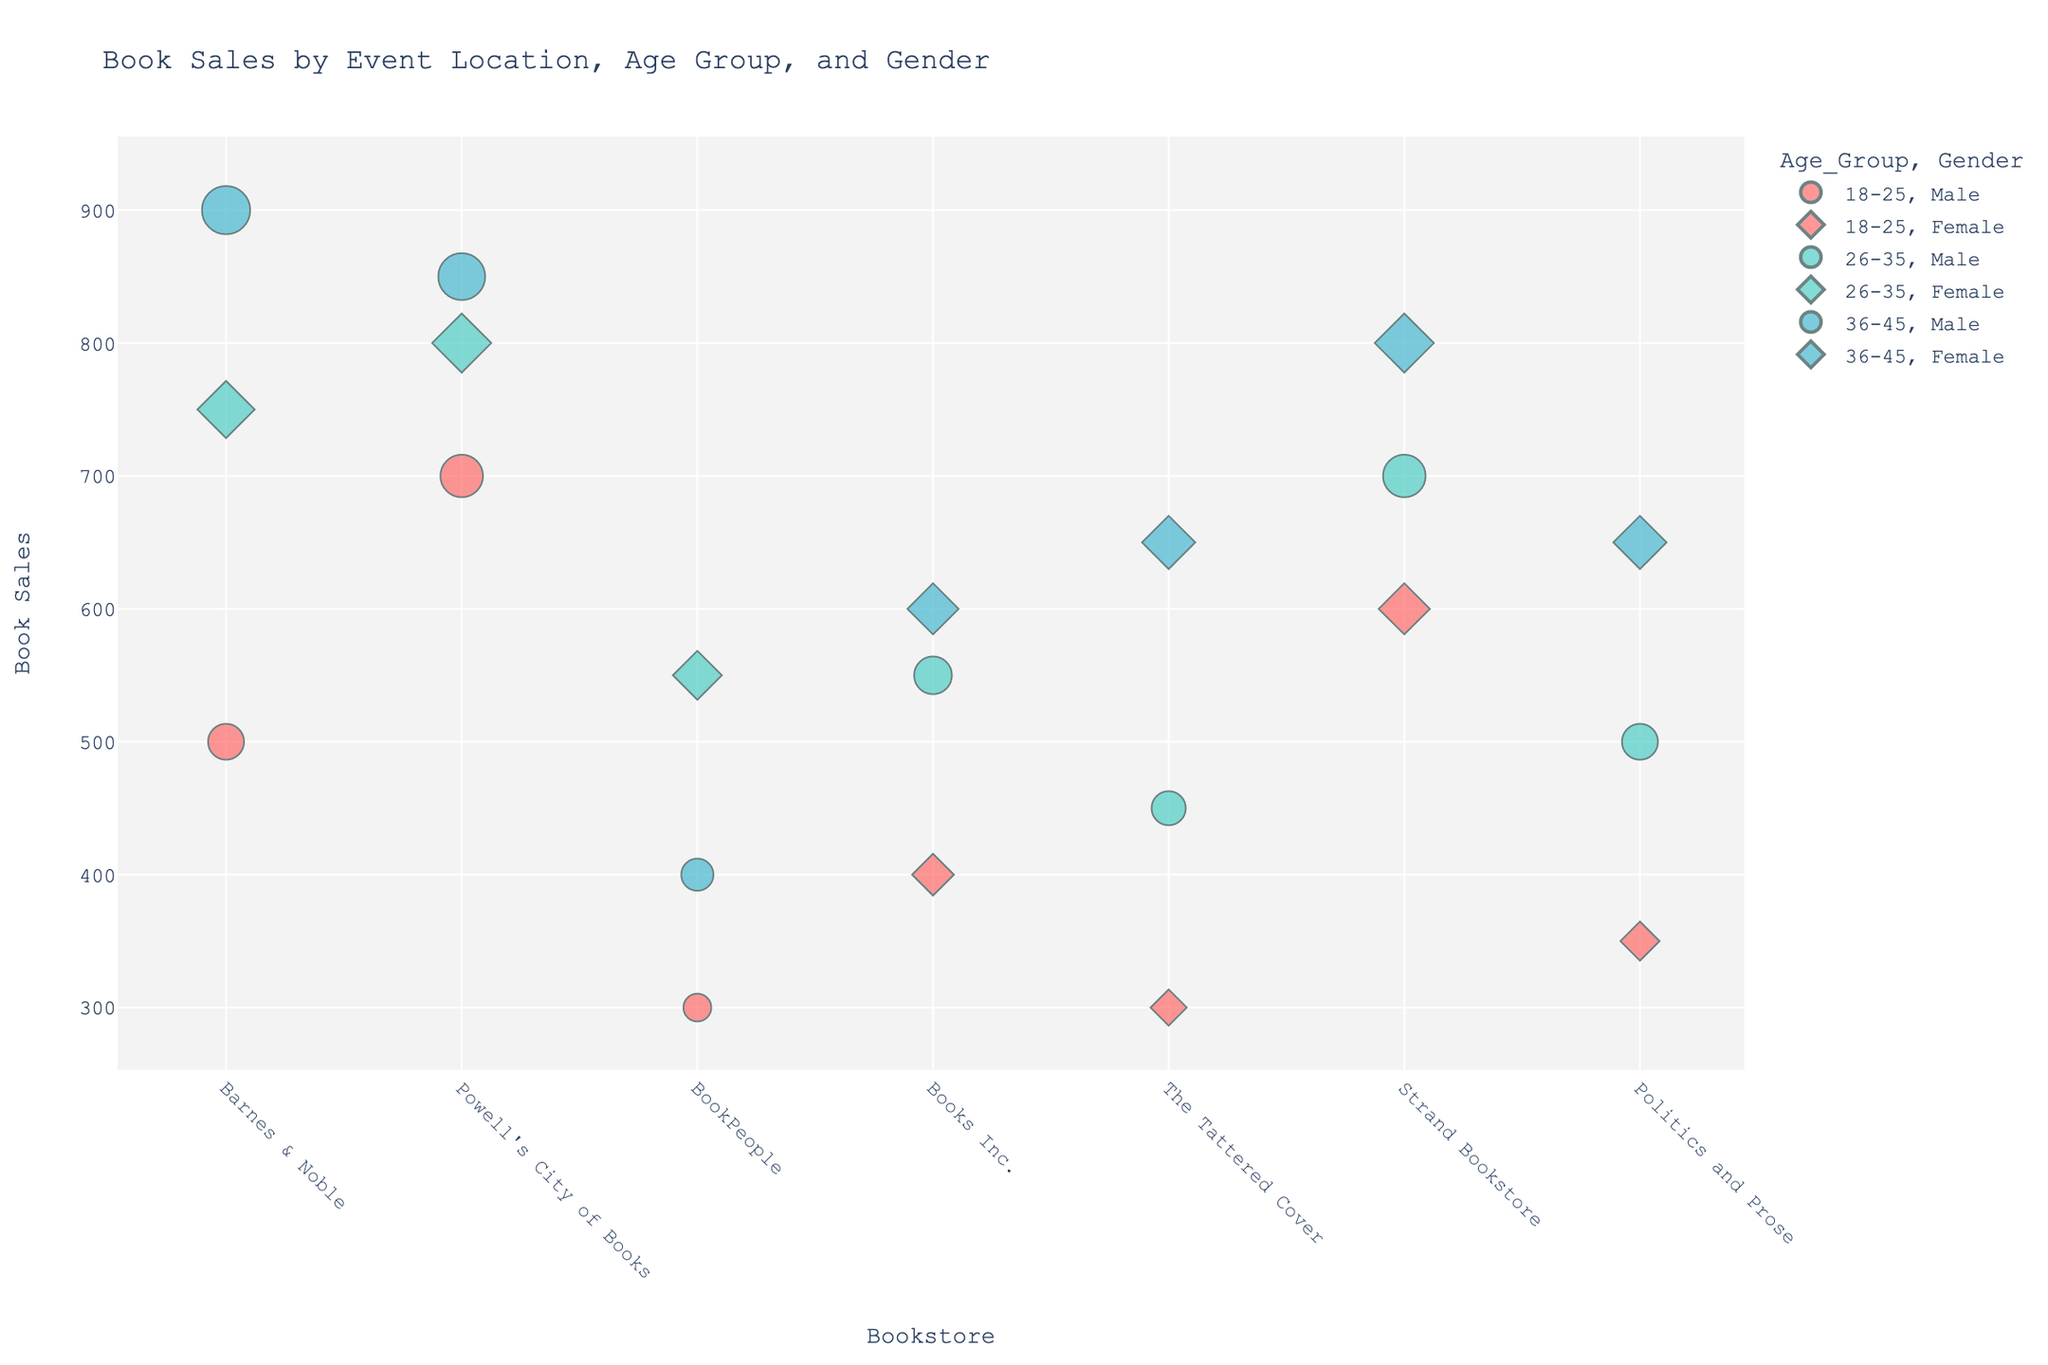what is the event location with the highest sales volume? The event location with the highest sales volume can be determined by identifying the marker with the largest size on the y-axis for Sales Volume. "Barnes & Noble" in New York, NY, has the highest sales volume at 900.
Answer: Barnes & Noble which age group had the highest sales volume at Powell's City of Books? To find this, look at the markers at "Powell's City of Books" and compare their sizes. The 36-45 age group had the highest sales volume at 850.
Answer: 36-45 how does the sales volume for males compare to females across all event locations? To compare, observe the size of the symbols for male versus female across all event locations. Males generally show larger sales volumes in both New York (Barnes & Noble) at 900 and Portland (Powell's City of Books) at 850. Females, while having significant sales volumes, do not surpass males in any given location.
Answer: Males have higher sales volumes what is the total sales volume for the 26-35 age group across all event locations? Sum the sales volumes for the 26-35 age group at each event location: 750 (Barnes & Noble) + 550 (Books Inc.) + 450 (The Tattered Cover) + 800 (Powell's City of Books) + 700 (Strand Bookstore) + 550 (BookPeople) + 500 (Politics and Prose) = 4300.
Answer: 4300 which location has the most balanced gender representation by sales volume? To determine this, compare the sales volumes of males and females at each location. The Tattered Cover in Denver shows balanced sales volumes with 450 for males and 300 & 650 for females, indicating a more equal representation.
Answer: The Tattered Cover how do the sales volumes compare between New York and Portland for the 18-25 age group? Compare the sales volumes for the 18-25 age group in New York (Barnes & Noble 500, Strand Bookstore 600) and Portland (Powell's City of Books 700). The combined sales volumes for each city are 1100 for New York and 700 for Portland.
Answer: New York has higher sales volumes (1100 vs. 700) which event location had the lowest sales volume for males? To find this, locate the smallest symbol for males on the y-axis for each event location. BookPeople in Austin, TX, had the lowest sales volume for males at 300.
Answer: BookPeople what is the median sales volume for the 36-45 age group across all event locations? List the sales volumes for the 36-45 age group: 900 (Barnes & Noble), 600 (Books Inc.), 650 (The Tattered Cover), 850 (Powell's City of Books), 800 (Strand Bookstore), 400 (BookPeople), 650 (Politics and Prose). After sorting (400, 600, 650, 650, 800, 850, 900), the median is 650.
Answer: 650 how does the sales volume in Austin compare to the sales volume in San Francisco for the 26-35 age group? Compare the sales volumes for the 26-35 age group: Austin (BookPeople) has 550, San Francisco (Books Inc.) has 550. Since both are equal, the sales volumes are the same.
Answer: Equal (550 vs. 550) in which location do females in the 18-25 age group have the highest sales? Look at each event location and find the largest symbol for females in the 18-25 age group. Strand Bookstore in New York, NY, shows the highest sales volume at 600.
Answer: Strand Bookstore 